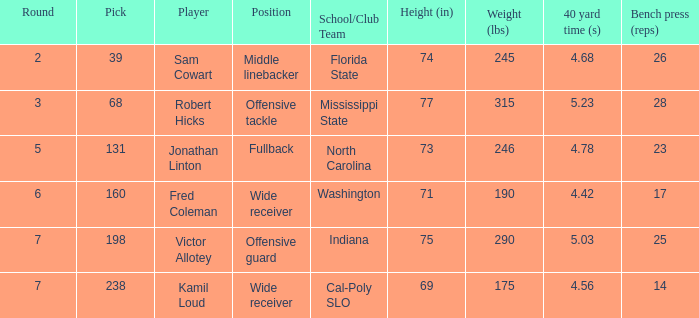Which Player has a Round smaller than 5, and a School/Club Team of florida state? Sam Cowart. 